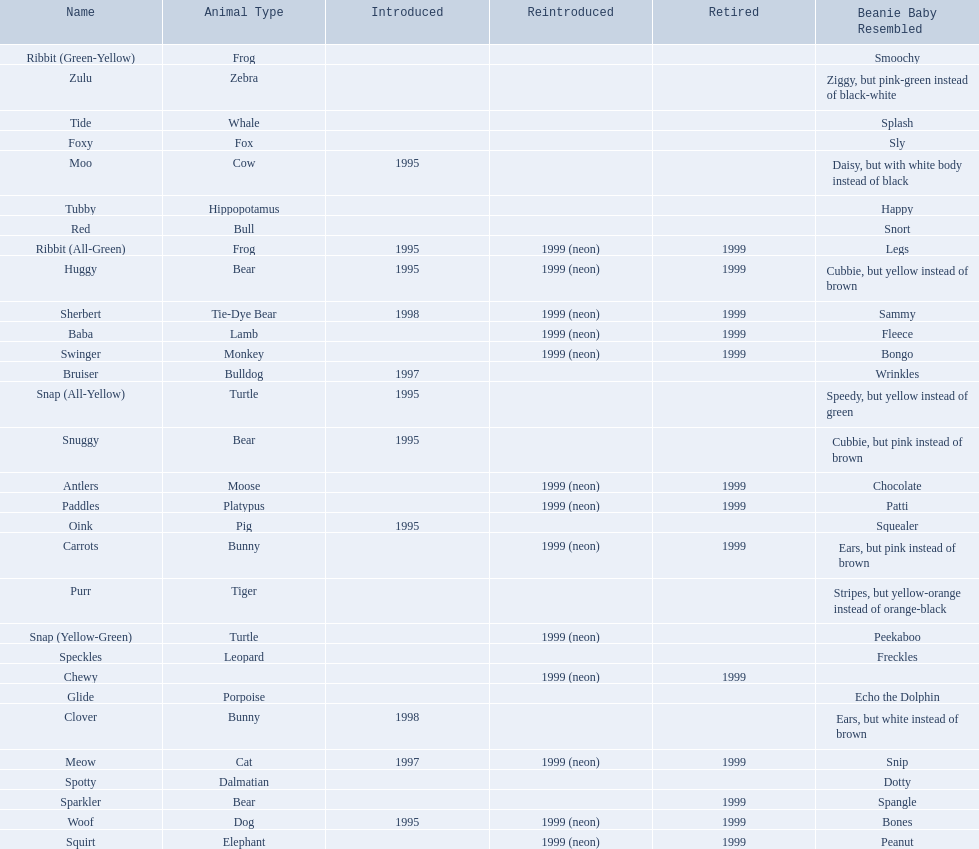What are the names listed? Antlers, Baba, Bruiser, Carrots, Chewy, Clover, Foxy, Glide, Huggy, Meow, Moo, Oink, Paddles, Purr, Red, Ribbit (All-Green), Ribbit (Green-Yellow), Sherbert, Snap (All-Yellow), Snap (Yellow-Green), Snuggy, Sparkler, Speckles, Spotty, Squirt, Swinger, Tide, Tubby, Woof, Zulu. Of these, which is the only pet without an animal type listed? Chewy. 